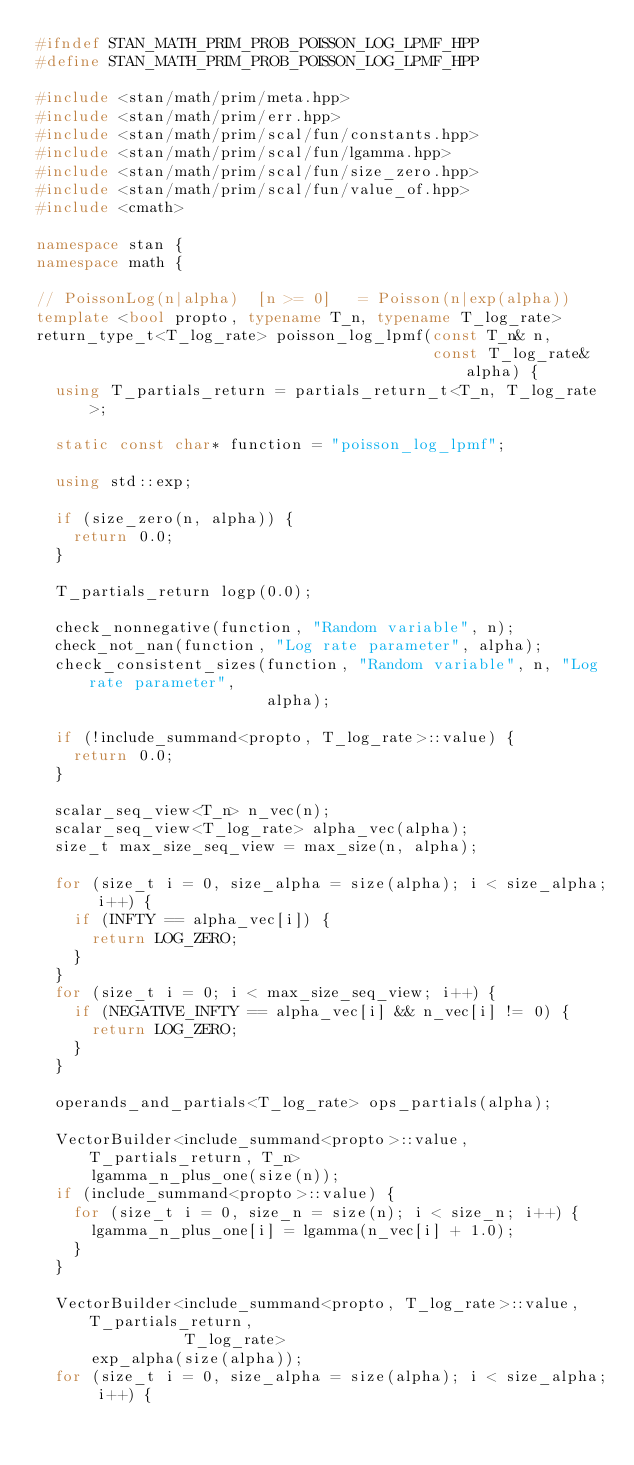Convert code to text. <code><loc_0><loc_0><loc_500><loc_500><_C++_>#ifndef STAN_MATH_PRIM_PROB_POISSON_LOG_LPMF_HPP
#define STAN_MATH_PRIM_PROB_POISSON_LOG_LPMF_HPP

#include <stan/math/prim/meta.hpp>
#include <stan/math/prim/err.hpp>
#include <stan/math/prim/scal/fun/constants.hpp>
#include <stan/math/prim/scal/fun/lgamma.hpp>
#include <stan/math/prim/scal/fun/size_zero.hpp>
#include <stan/math/prim/scal/fun/value_of.hpp>
#include <cmath>

namespace stan {
namespace math {

// PoissonLog(n|alpha)  [n >= 0]   = Poisson(n|exp(alpha))
template <bool propto, typename T_n, typename T_log_rate>
return_type_t<T_log_rate> poisson_log_lpmf(const T_n& n,
                                           const T_log_rate& alpha) {
  using T_partials_return = partials_return_t<T_n, T_log_rate>;

  static const char* function = "poisson_log_lpmf";

  using std::exp;

  if (size_zero(n, alpha)) {
    return 0.0;
  }

  T_partials_return logp(0.0);

  check_nonnegative(function, "Random variable", n);
  check_not_nan(function, "Log rate parameter", alpha);
  check_consistent_sizes(function, "Random variable", n, "Log rate parameter",
                         alpha);

  if (!include_summand<propto, T_log_rate>::value) {
    return 0.0;
  }

  scalar_seq_view<T_n> n_vec(n);
  scalar_seq_view<T_log_rate> alpha_vec(alpha);
  size_t max_size_seq_view = max_size(n, alpha);

  for (size_t i = 0, size_alpha = size(alpha); i < size_alpha; i++) {
    if (INFTY == alpha_vec[i]) {
      return LOG_ZERO;
    }
  }
  for (size_t i = 0; i < max_size_seq_view; i++) {
    if (NEGATIVE_INFTY == alpha_vec[i] && n_vec[i] != 0) {
      return LOG_ZERO;
    }
  }

  operands_and_partials<T_log_rate> ops_partials(alpha);

  VectorBuilder<include_summand<propto>::value, T_partials_return, T_n>
      lgamma_n_plus_one(size(n));
  if (include_summand<propto>::value) {
    for (size_t i = 0, size_n = size(n); i < size_n; i++) {
      lgamma_n_plus_one[i] = lgamma(n_vec[i] + 1.0);
    }
  }

  VectorBuilder<include_summand<propto, T_log_rate>::value, T_partials_return,
                T_log_rate>
      exp_alpha(size(alpha));
  for (size_t i = 0, size_alpha = size(alpha); i < size_alpha; i++) {</code> 